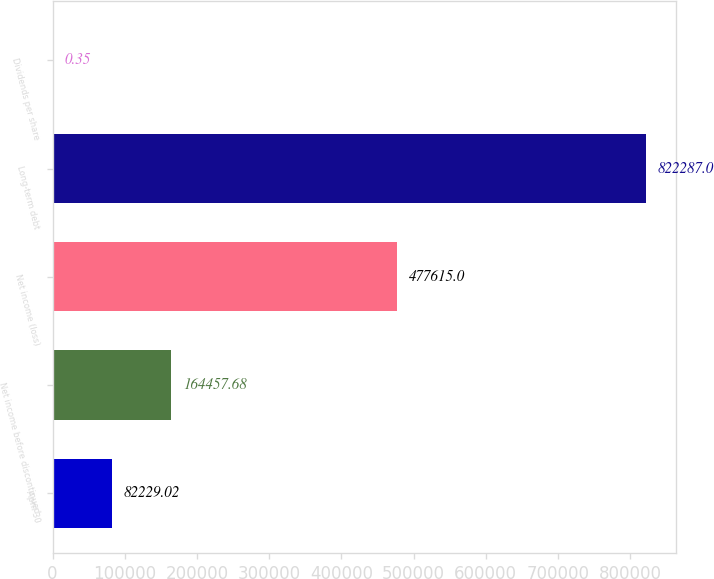Convert chart to OTSL. <chart><loc_0><loc_0><loc_500><loc_500><bar_chart><fcel>April 30<fcel>Net income before discontinued<fcel>Net income (loss)<fcel>Long-term debt<fcel>Dividends per share<nl><fcel>82229<fcel>164458<fcel>477615<fcel>822287<fcel>0.35<nl></chart> 